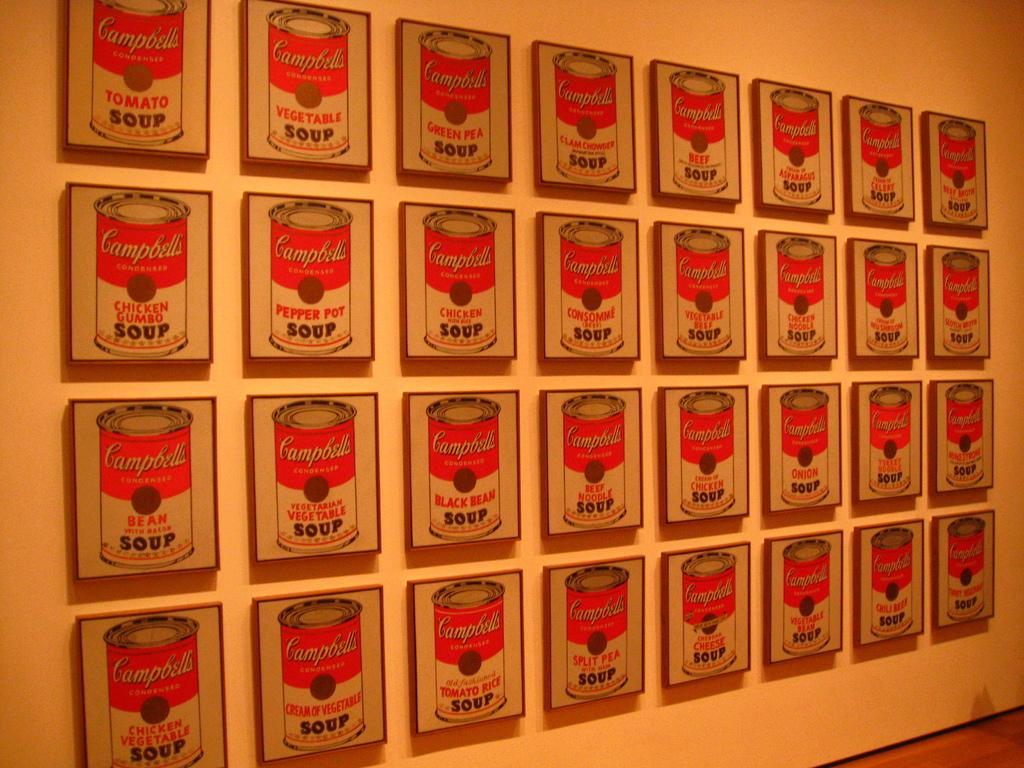<image>
Describe the image concisely. A series of pictures of a variety of Campbell's Soups are displayed and include a number of different flavors. 